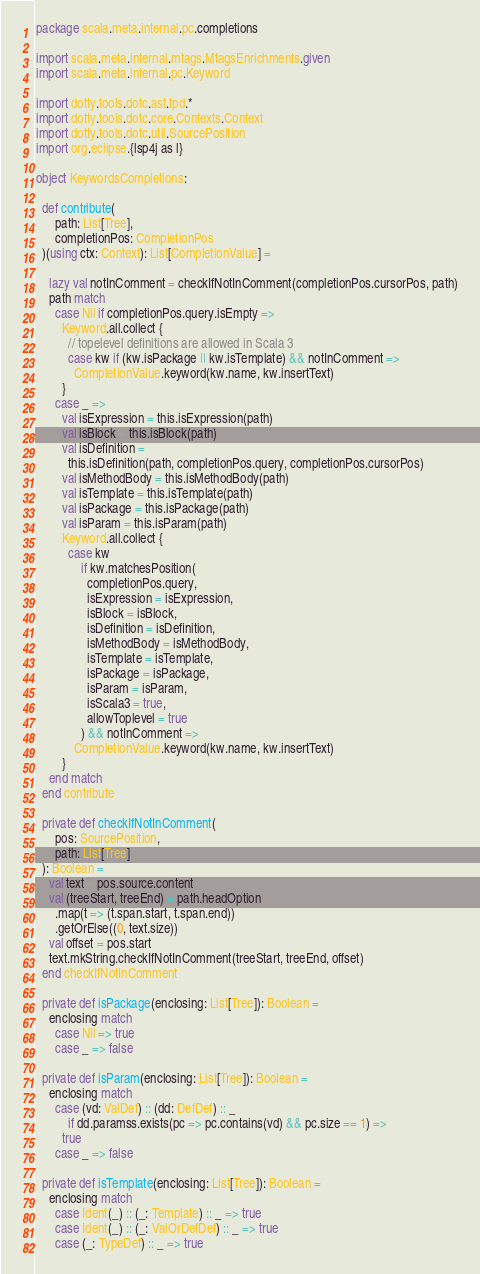Convert code to text. <code><loc_0><loc_0><loc_500><loc_500><_Scala_>package scala.meta.internal.pc.completions

import scala.meta.internal.mtags.MtagsEnrichments.given
import scala.meta.internal.pc.Keyword

import dotty.tools.dotc.ast.tpd.*
import dotty.tools.dotc.core.Contexts.Context
import dotty.tools.dotc.util.SourcePosition
import org.eclipse.{lsp4j as l}

object KeywordsCompletions:

  def contribute(
      path: List[Tree],
      completionPos: CompletionPos
  )(using ctx: Context): List[CompletionValue] =

    lazy val notInComment = checkIfNotInComment(completionPos.cursorPos, path)
    path match
      case Nil if completionPos.query.isEmpty =>
        Keyword.all.collect {
          // topelevel definitions are allowed in Scala 3
          case kw if (kw.isPackage || kw.isTemplate) && notInComment =>
            CompletionValue.keyword(kw.name, kw.insertText)
        }
      case _ =>
        val isExpression = this.isExpression(path)
        val isBlock = this.isBlock(path)
        val isDefinition =
          this.isDefinition(path, completionPos.query, completionPos.cursorPos)
        val isMethodBody = this.isMethodBody(path)
        val isTemplate = this.isTemplate(path)
        val isPackage = this.isPackage(path)
        val isParam = this.isParam(path)
        Keyword.all.collect {
          case kw
              if kw.matchesPosition(
                completionPos.query,
                isExpression = isExpression,
                isBlock = isBlock,
                isDefinition = isDefinition,
                isMethodBody = isMethodBody,
                isTemplate = isTemplate,
                isPackage = isPackage,
                isParam = isParam,
                isScala3 = true,
                allowToplevel = true
              ) && notInComment =>
            CompletionValue.keyword(kw.name, kw.insertText)
        }
    end match
  end contribute

  private def checkIfNotInComment(
      pos: SourcePosition,
      path: List[Tree]
  ): Boolean =
    val text = pos.source.content
    val (treeStart, treeEnd) = path.headOption
      .map(t => (t.span.start, t.span.end))
      .getOrElse((0, text.size))
    val offset = pos.start
    text.mkString.checkIfNotInComment(treeStart, treeEnd, offset)
  end checkIfNotInComment

  private def isPackage(enclosing: List[Tree]): Boolean =
    enclosing match
      case Nil => true
      case _ => false

  private def isParam(enclosing: List[Tree]): Boolean =
    enclosing match
      case (vd: ValDef) :: (dd: DefDef) :: _
          if dd.paramss.exists(pc => pc.contains(vd) && pc.size == 1) =>
        true
      case _ => false

  private def isTemplate(enclosing: List[Tree]): Boolean =
    enclosing match
      case Ident(_) :: (_: Template) :: _ => true
      case Ident(_) :: (_: ValOrDefDef) :: _ => true
      case (_: TypeDef) :: _ => true</code> 